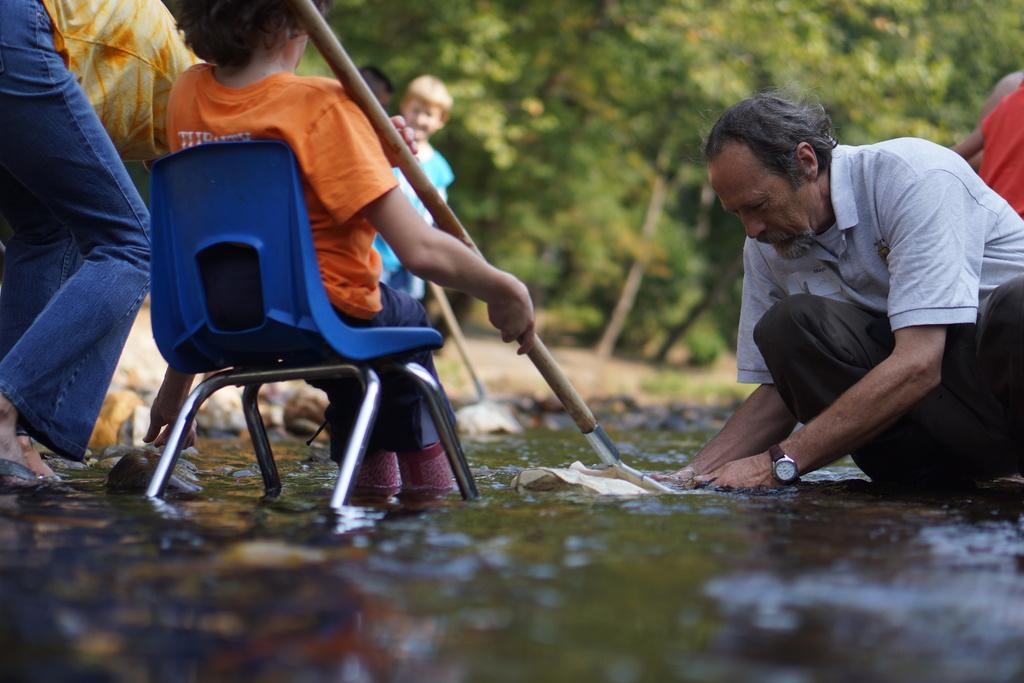What is happening in the image involving a group of people? There is a man sitting and doing some work, and a child is sitting on a chair. What is the child holding in the image? The child is holding a stick. Can you describe the background of the image? There is a tree in the background of the image. What type of dirt can be seen on the fowl in the image? There is no fowl present in the image, so it is not possible to determine the type of dirt on it. 